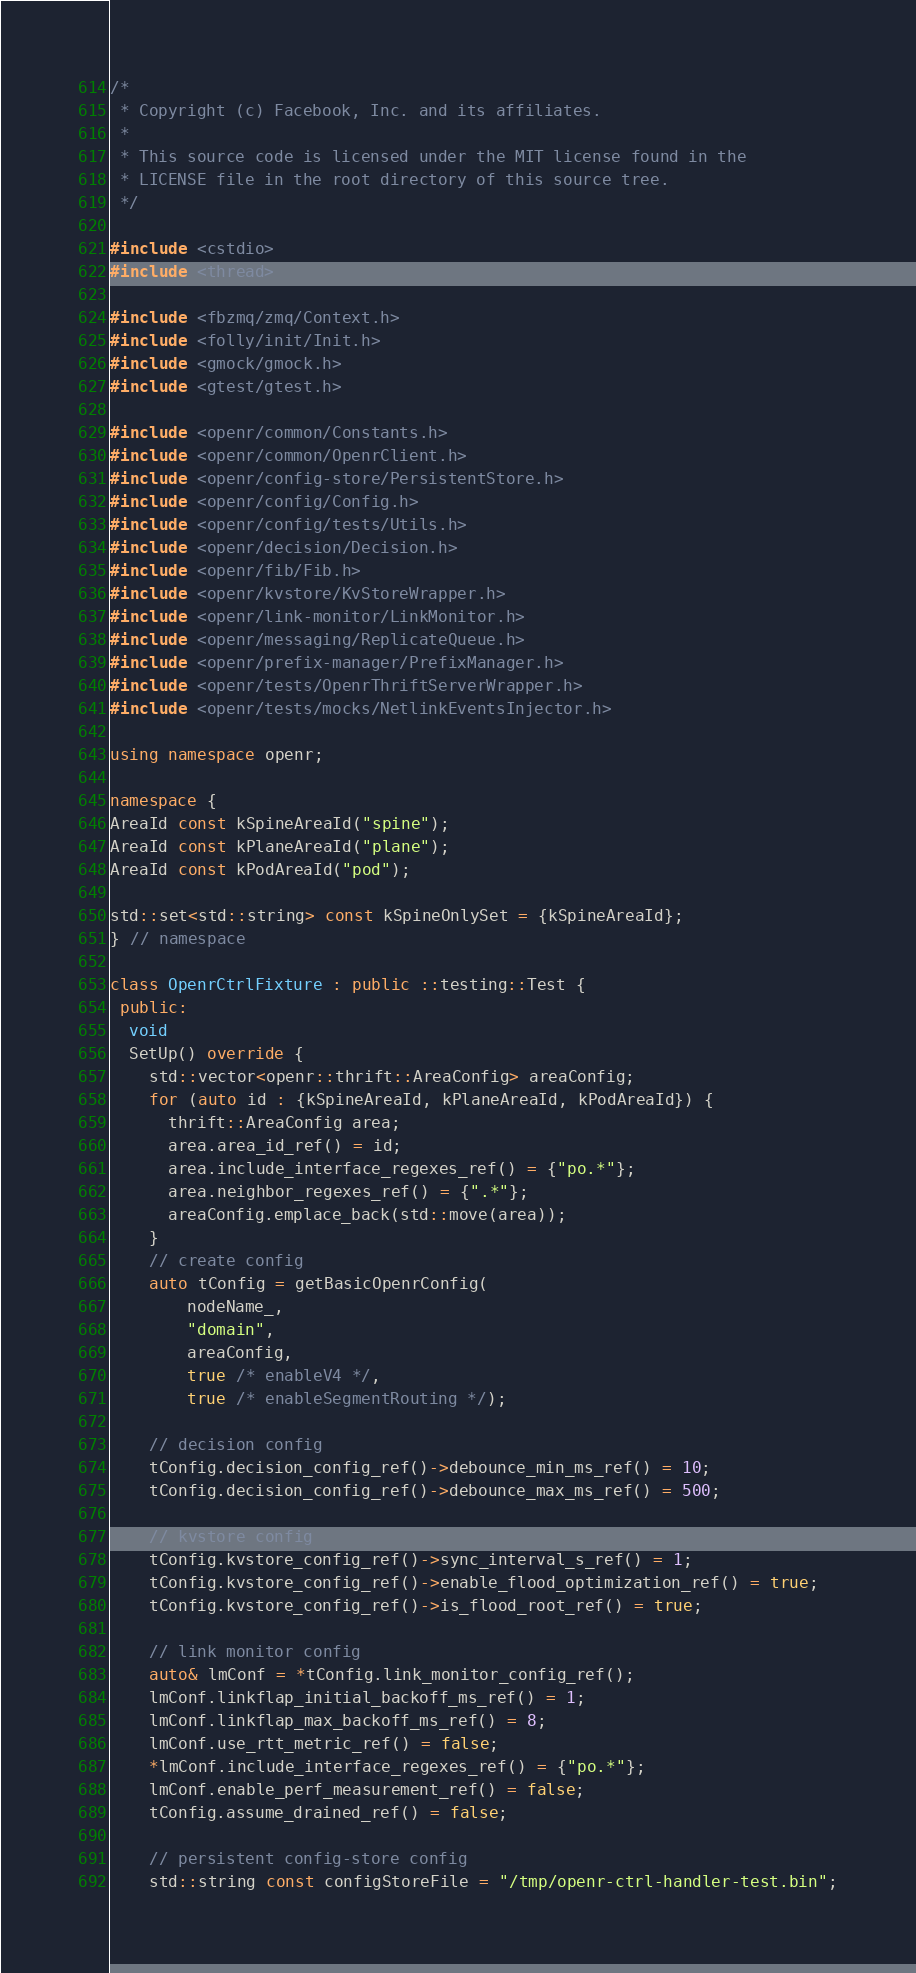<code> <loc_0><loc_0><loc_500><loc_500><_C++_>/*
 * Copyright (c) Facebook, Inc. and its affiliates.
 *
 * This source code is licensed under the MIT license found in the
 * LICENSE file in the root directory of this source tree.
 */

#include <cstdio>
#include <thread>

#include <fbzmq/zmq/Context.h>
#include <folly/init/Init.h>
#include <gmock/gmock.h>
#include <gtest/gtest.h>

#include <openr/common/Constants.h>
#include <openr/common/OpenrClient.h>
#include <openr/config-store/PersistentStore.h>
#include <openr/config/Config.h>
#include <openr/config/tests/Utils.h>
#include <openr/decision/Decision.h>
#include <openr/fib/Fib.h>
#include <openr/kvstore/KvStoreWrapper.h>
#include <openr/link-monitor/LinkMonitor.h>
#include <openr/messaging/ReplicateQueue.h>
#include <openr/prefix-manager/PrefixManager.h>
#include <openr/tests/OpenrThriftServerWrapper.h>
#include <openr/tests/mocks/NetlinkEventsInjector.h>

using namespace openr;

namespace {
AreaId const kSpineAreaId("spine");
AreaId const kPlaneAreaId("plane");
AreaId const kPodAreaId("pod");

std::set<std::string> const kSpineOnlySet = {kSpineAreaId};
} // namespace

class OpenrCtrlFixture : public ::testing::Test {
 public:
  void
  SetUp() override {
    std::vector<openr::thrift::AreaConfig> areaConfig;
    for (auto id : {kSpineAreaId, kPlaneAreaId, kPodAreaId}) {
      thrift::AreaConfig area;
      area.area_id_ref() = id;
      area.include_interface_regexes_ref() = {"po.*"};
      area.neighbor_regexes_ref() = {".*"};
      areaConfig.emplace_back(std::move(area));
    }
    // create config
    auto tConfig = getBasicOpenrConfig(
        nodeName_,
        "domain",
        areaConfig,
        true /* enableV4 */,
        true /* enableSegmentRouting */);

    // decision config
    tConfig.decision_config_ref()->debounce_min_ms_ref() = 10;
    tConfig.decision_config_ref()->debounce_max_ms_ref() = 500;

    // kvstore config
    tConfig.kvstore_config_ref()->sync_interval_s_ref() = 1;
    tConfig.kvstore_config_ref()->enable_flood_optimization_ref() = true;
    tConfig.kvstore_config_ref()->is_flood_root_ref() = true;

    // link monitor config
    auto& lmConf = *tConfig.link_monitor_config_ref();
    lmConf.linkflap_initial_backoff_ms_ref() = 1;
    lmConf.linkflap_max_backoff_ms_ref() = 8;
    lmConf.use_rtt_metric_ref() = false;
    *lmConf.include_interface_regexes_ref() = {"po.*"};
    lmConf.enable_perf_measurement_ref() = false;
    tConfig.assume_drained_ref() = false;

    // persistent config-store config
    std::string const configStoreFile = "/tmp/openr-ctrl-handler-test.bin";</code> 